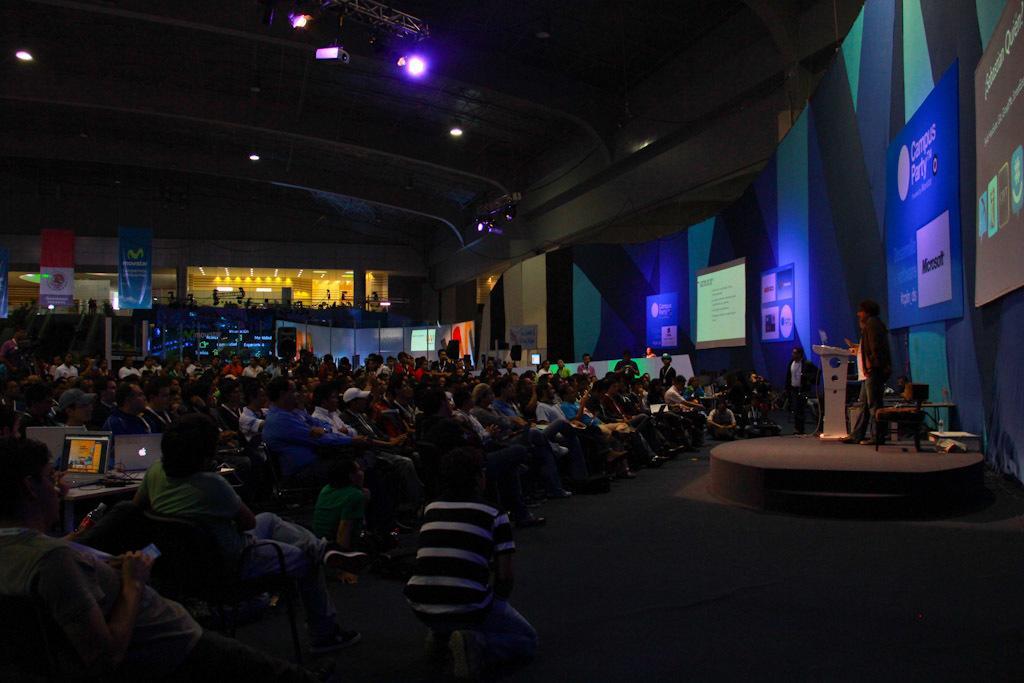Describe this image in one or two sentences. These group of people are sitting on a chair. On this table there is a laptop. On top there is a focusing light and projector. These are banners. On this stage there is a podium and a person is standing. Far there are banners. 